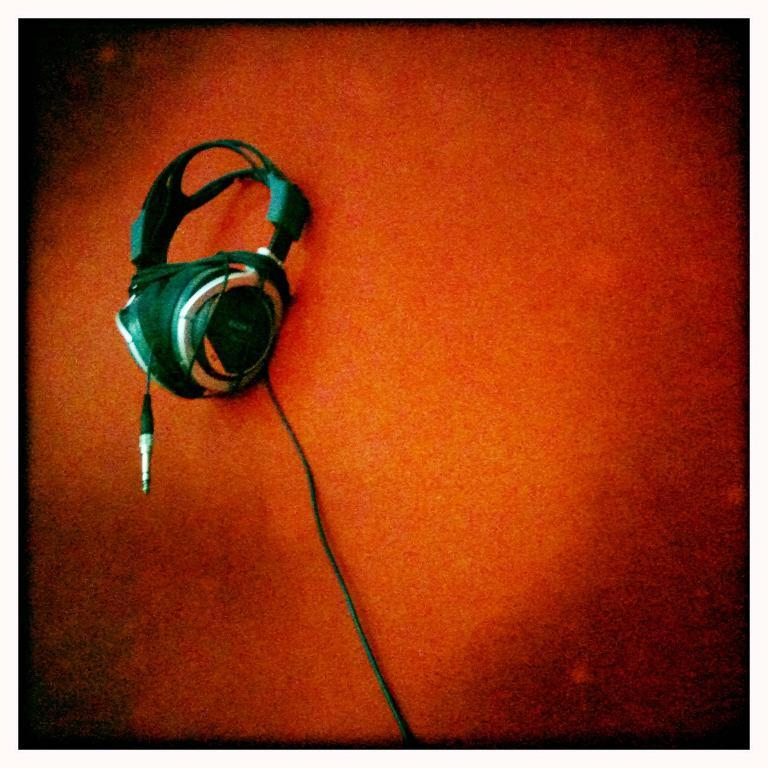What is the primary surface visible in the image? There is a floor visible in the image. What object is located in the foreground of the image? There is a headset in the foreground of the image. What type of ornament is hanging from the elbow of the person in the image? There is no person or elbow visible in the image, so it is not possible to determine if there is an ornament hanging from it. 